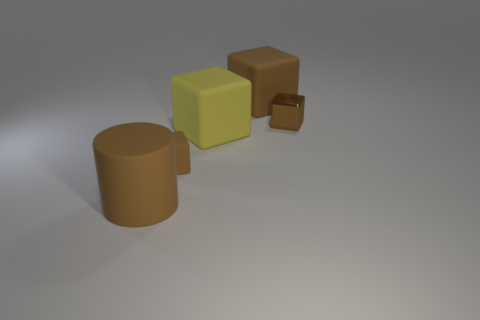Subtract all green spheres. How many brown cubes are left? 3 Add 3 big brown cylinders. How many objects exist? 8 Subtract all cubes. How many objects are left? 1 Subtract 0 brown balls. How many objects are left? 5 Subtract all tiny objects. Subtract all yellow rubber objects. How many objects are left? 2 Add 4 tiny cubes. How many tiny cubes are left? 6 Add 1 brown matte blocks. How many brown matte blocks exist? 3 